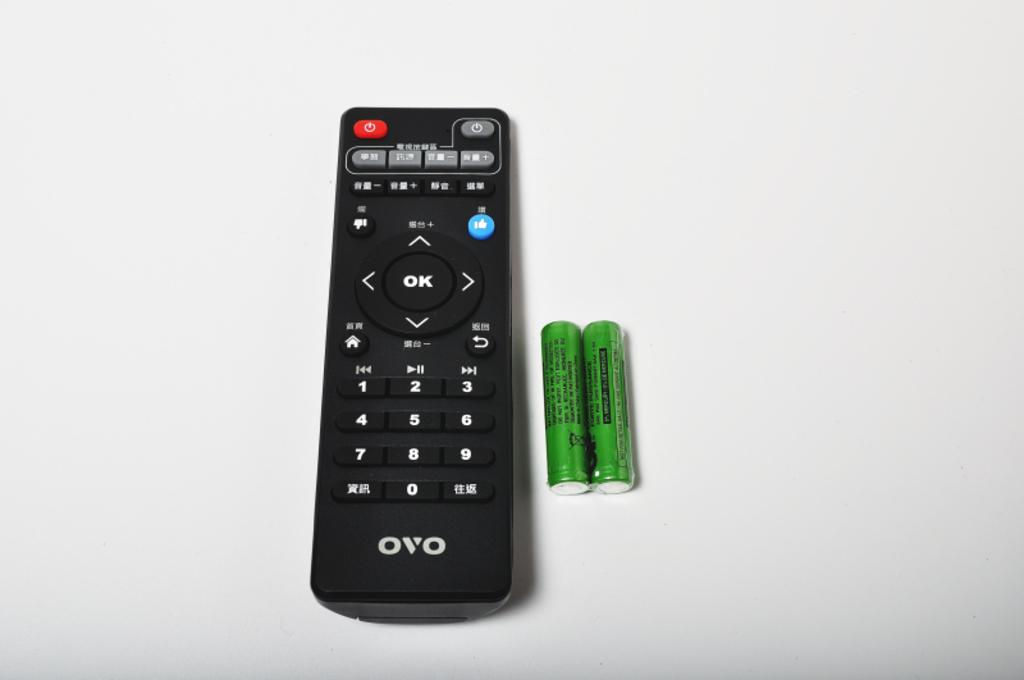<image>
Summarize the visual content of the image. An OVO remote control with two batteries beside it. 